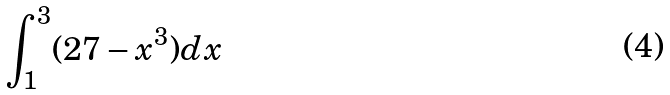Convert formula to latex. <formula><loc_0><loc_0><loc_500><loc_500>\int _ { 1 } ^ { 3 } ( 2 7 - x ^ { 3 } ) d x</formula> 